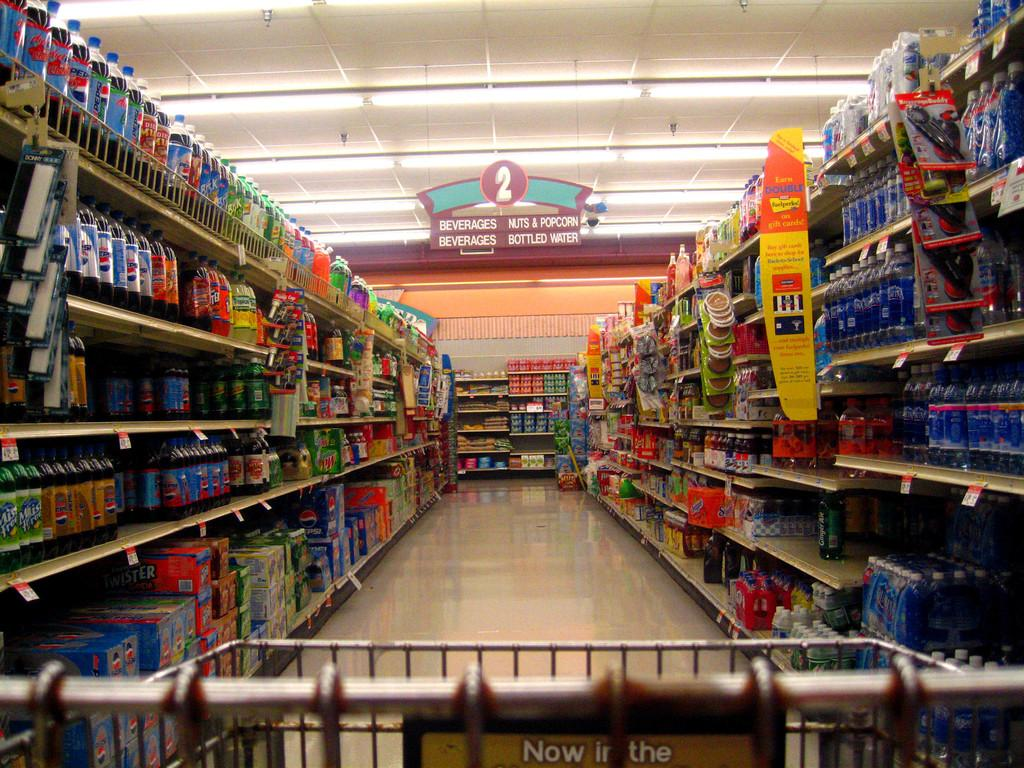<image>
Create a compact narrative representing the image presented. The aisle in a store where Nuts & Popcorn can be found 